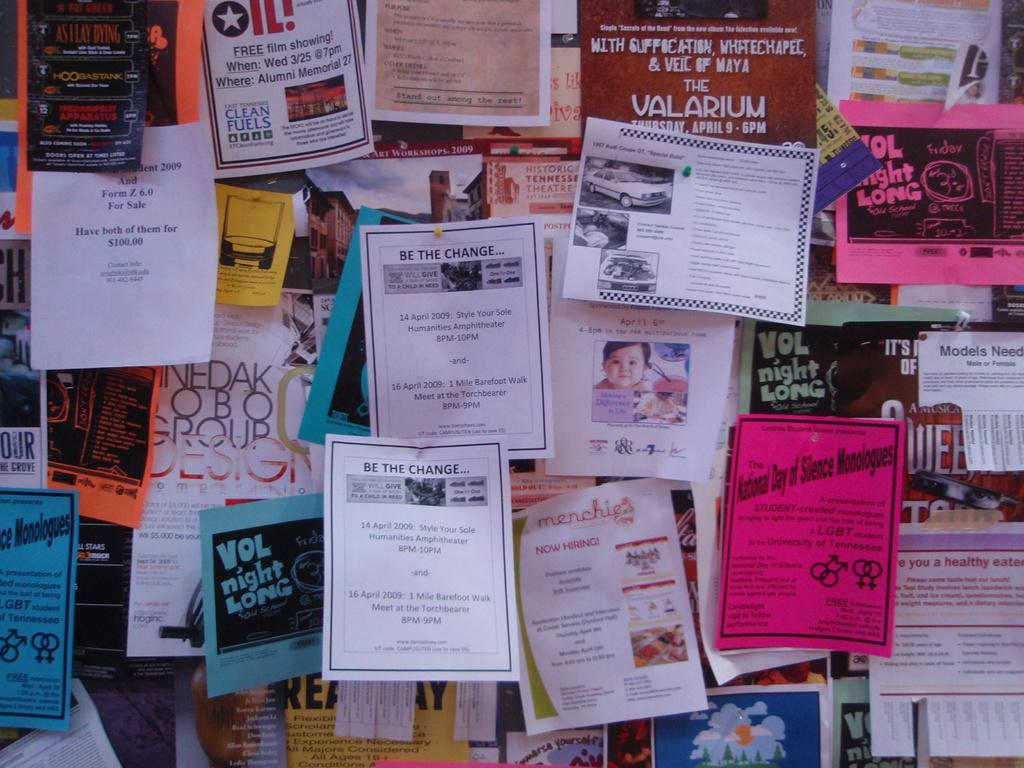What type of printed materials can be seen in the image? There are pamphlets in the image. Can you describe the variety of pamphlets present? The pamphlets come in different types. What type of stocking is being worn by the tramp in the image? There is no tramp or stocking present in the image; it only features pamphlets. 